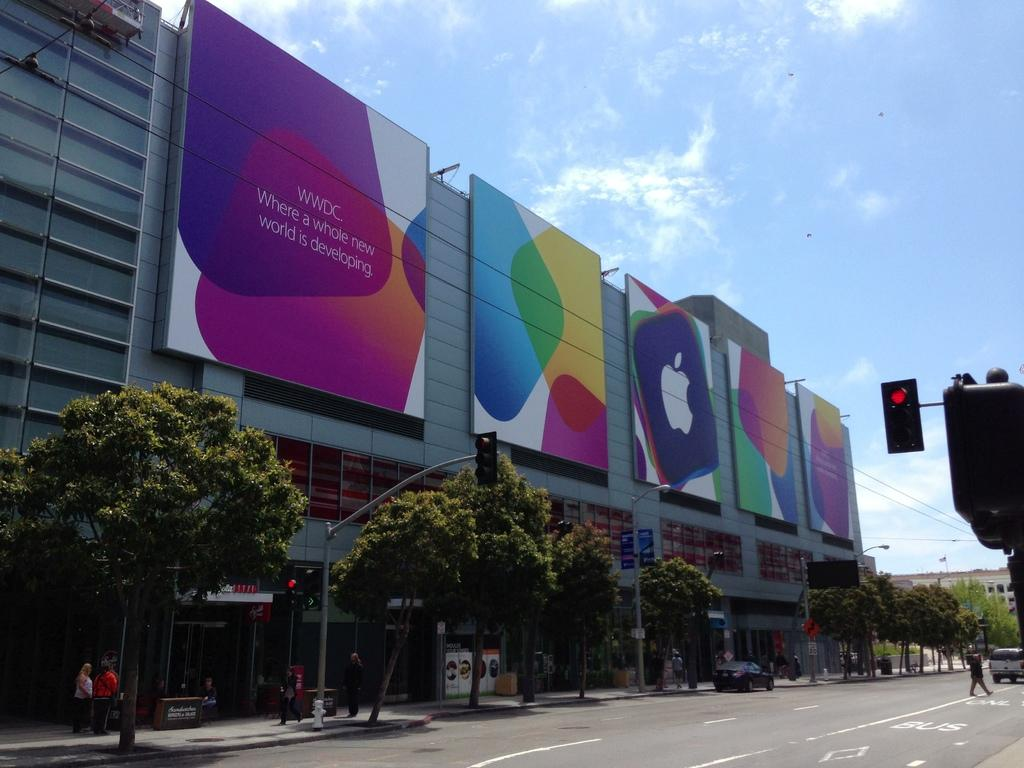<image>
Write a terse but informative summary of the picture. A huge apple store with a sign that says WWDC on it. 